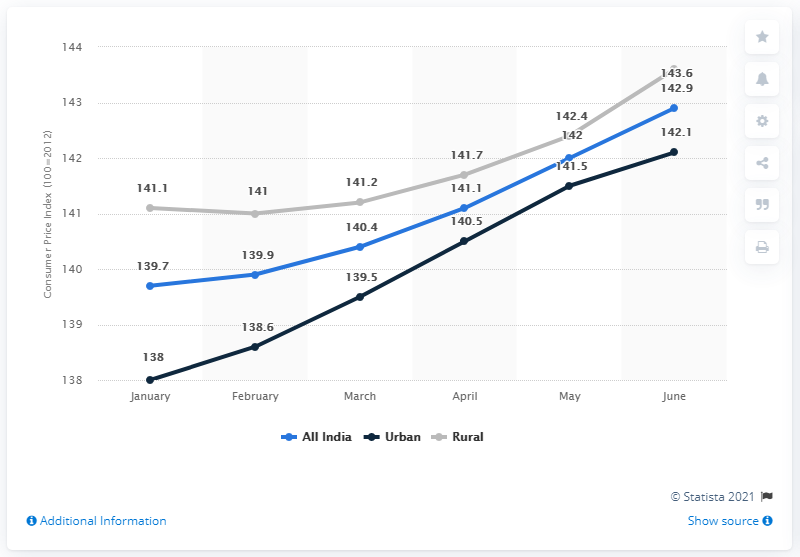Indicate a few pertinent items in this graphic. In June 2019, the Consumer Price Index in India was 142.9. 